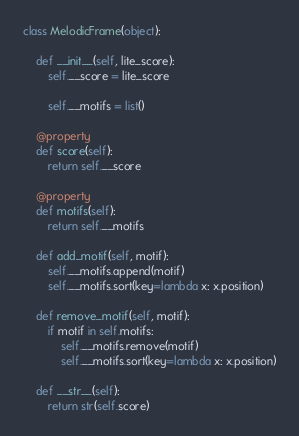<code> <loc_0><loc_0><loc_500><loc_500><_Python_>

class MelodicFrame(object):

    def __init__(self, lite_score):
        self.__score = lite_score

        self.__motifs = list()

    @property
    def score(self):
        return self.__score

    @property
    def motifs(self):
        return self.__motifs

    def add_motif(self, motif):
        self.__motifs.append(motif)
        self.__motifs.sort(key=lambda x: x.position)

    def remove_motif(self, motif):
        if motif in self.motifs:
            self.__motifs.remove(motif)
            self.__motifs.sort(key=lambda x: x.position)

    def __str__(self):
        return str(self.score)</code> 